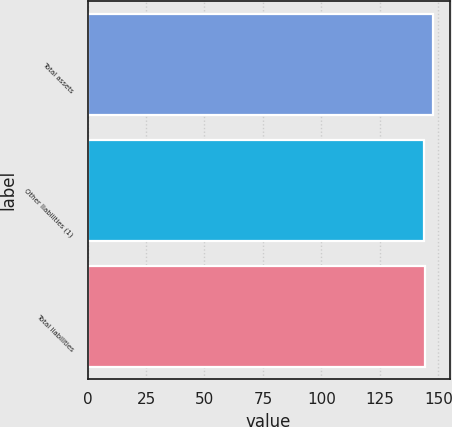Convert chart to OTSL. <chart><loc_0><loc_0><loc_500><loc_500><bar_chart><fcel>Total assets<fcel>Other liabilities (1)<fcel>Total liabilities<nl><fcel>147.5<fcel>143.8<fcel>144.17<nl></chart> 